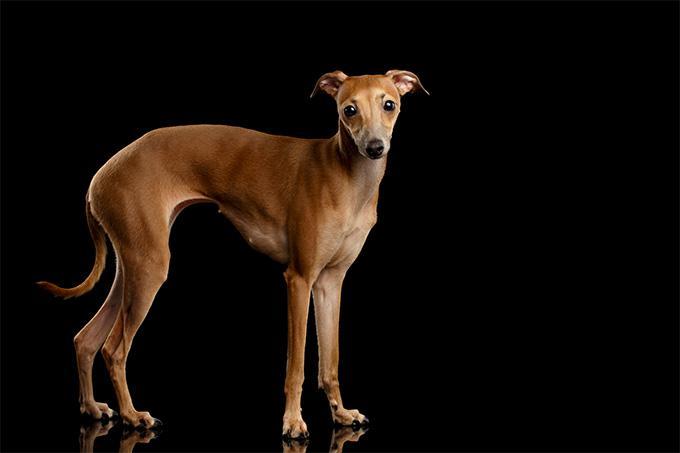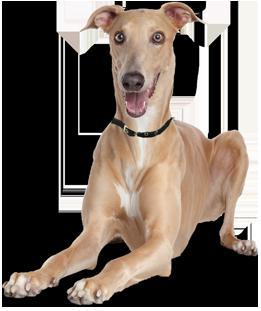The first image is the image on the left, the second image is the image on the right. Analyze the images presented: Is the assertion "Dog has a grey (blue) and white color." valid? Answer yes or no. No. 